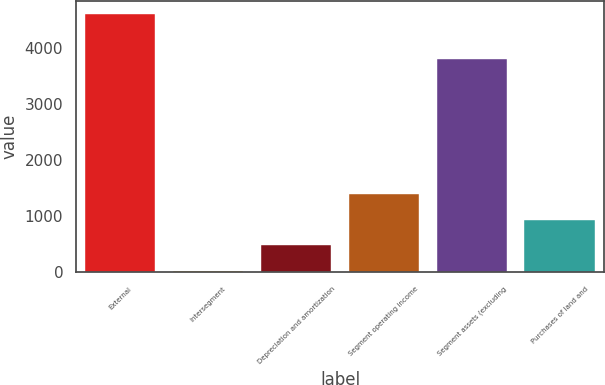Convert chart to OTSL. <chart><loc_0><loc_0><loc_500><loc_500><bar_chart><fcel>External<fcel>Intersegment<fcel>Depreciation and amortization<fcel>Segment operating income<fcel>Segment assets (excluding<fcel>Purchases of land and<nl><fcel>4614.7<fcel>24.9<fcel>483.88<fcel>1401.84<fcel>3813.3<fcel>942.86<nl></chart> 